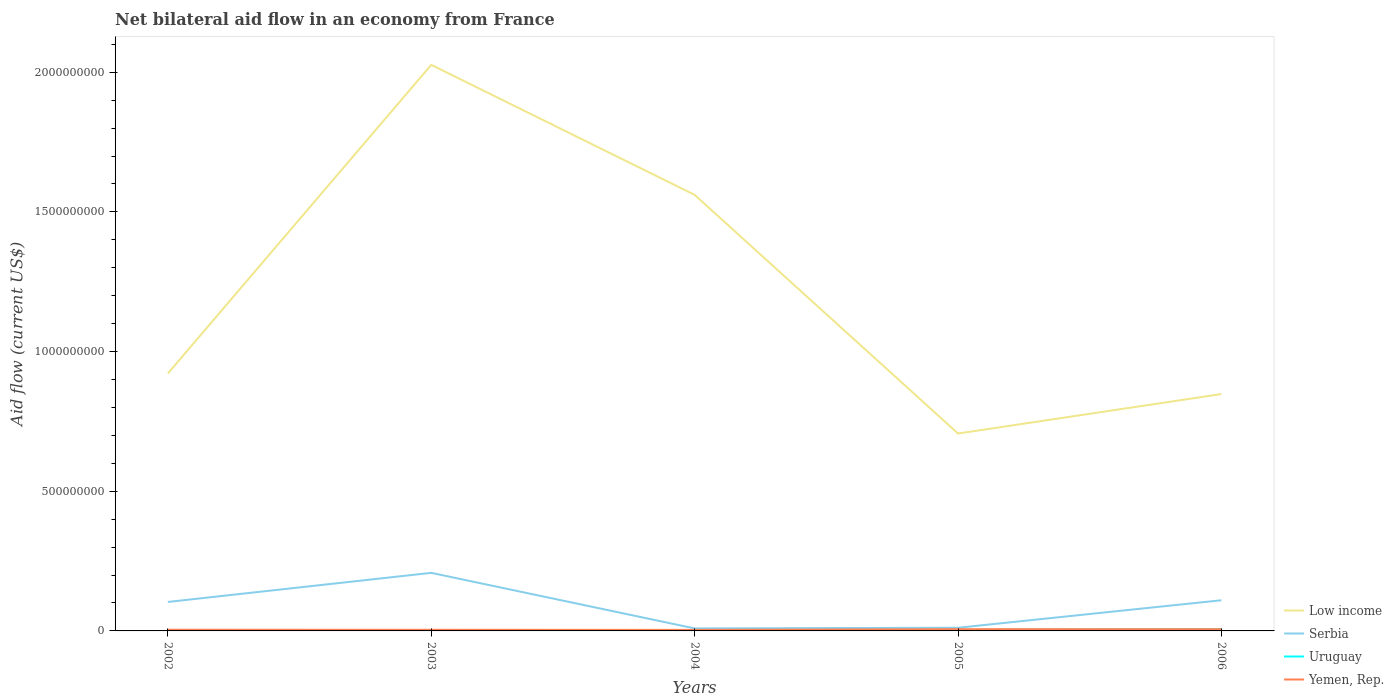Does the line corresponding to Low income intersect with the line corresponding to Uruguay?
Offer a terse response. No. Across all years, what is the maximum net bilateral aid flow in Low income?
Provide a short and direct response. 7.07e+08. What is the total net bilateral aid flow in Uruguay in the graph?
Keep it short and to the point. -3.06e+06. What is the difference between the highest and the second highest net bilateral aid flow in Serbia?
Provide a short and direct response. 1.99e+08. What is the difference between the highest and the lowest net bilateral aid flow in Yemen, Rep.?
Give a very brief answer. 2. Are the values on the major ticks of Y-axis written in scientific E-notation?
Your answer should be compact. No. How many legend labels are there?
Your response must be concise. 4. What is the title of the graph?
Offer a very short reply. Net bilateral aid flow in an economy from France. Does "Equatorial Guinea" appear as one of the legend labels in the graph?
Ensure brevity in your answer.  No. What is the label or title of the X-axis?
Ensure brevity in your answer.  Years. What is the label or title of the Y-axis?
Provide a short and direct response. Aid flow (current US$). What is the Aid flow (current US$) in Low income in 2002?
Your response must be concise. 9.22e+08. What is the Aid flow (current US$) in Serbia in 2002?
Provide a succinct answer. 1.04e+08. What is the Aid flow (current US$) in Uruguay in 2002?
Give a very brief answer. 2.39e+06. What is the Aid flow (current US$) of Yemen, Rep. in 2002?
Keep it short and to the point. 4.20e+06. What is the Aid flow (current US$) of Low income in 2003?
Ensure brevity in your answer.  2.03e+09. What is the Aid flow (current US$) of Serbia in 2003?
Offer a very short reply. 2.08e+08. What is the Aid flow (current US$) in Uruguay in 2003?
Make the answer very short. 1.96e+06. What is the Aid flow (current US$) in Yemen, Rep. in 2003?
Make the answer very short. 4.08e+06. What is the Aid flow (current US$) in Low income in 2004?
Provide a short and direct response. 1.56e+09. What is the Aid flow (current US$) in Serbia in 2004?
Your answer should be very brief. 8.95e+06. What is the Aid flow (current US$) of Uruguay in 2004?
Provide a short and direct response. 3.28e+06. What is the Aid flow (current US$) in Yemen, Rep. in 2004?
Offer a very short reply. 3.67e+06. What is the Aid flow (current US$) of Low income in 2005?
Offer a very short reply. 7.07e+08. What is the Aid flow (current US$) in Serbia in 2005?
Your response must be concise. 1.13e+07. What is the Aid flow (current US$) of Uruguay in 2005?
Offer a very short reply. 3.69e+06. What is the Aid flow (current US$) in Yemen, Rep. in 2005?
Ensure brevity in your answer.  6.19e+06. What is the Aid flow (current US$) of Low income in 2006?
Keep it short and to the point. 8.48e+08. What is the Aid flow (current US$) in Serbia in 2006?
Provide a short and direct response. 1.10e+08. What is the Aid flow (current US$) in Uruguay in 2006?
Your response must be concise. 6.34e+06. What is the Aid flow (current US$) in Yemen, Rep. in 2006?
Make the answer very short. 6.10e+06. Across all years, what is the maximum Aid flow (current US$) of Low income?
Your answer should be compact. 2.03e+09. Across all years, what is the maximum Aid flow (current US$) in Serbia?
Provide a short and direct response. 2.08e+08. Across all years, what is the maximum Aid flow (current US$) of Uruguay?
Your response must be concise. 6.34e+06. Across all years, what is the maximum Aid flow (current US$) of Yemen, Rep.?
Make the answer very short. 6.19e+06. Across all years, what is the minimum Aid flow (current US$) in Low income?
Offer a very short reply. 7.07e+08. Across all years, what is the minimum Aid flow (current US$) in Serbia?
Provide a short and direct response. 8.95e+06. Across all years, what is the minimum Aid flow (current US$) in Uruguay?
Provide a succinct answer. 1.96e+06. Across all years, what is the minimum Aid flow (current US$) of Yemen, Rep.?
Your answer should be compact. 3.67e+06. What is the total Aid flow (current US$) in Low income in the graph?
Provide a succinct answer. 6.06e+09. What is the total Aid flow (current US$) of Serbia in the graph?
Offer a very short reply. 4.42e+08. What is the total Aid flow (current US$) of Uruguay in the graph?
Offer a terse response. 1.77e+07. What is the total Aid flow (current US$) in Yemen, Rep. in the graph?
Offer a very short reply. 2.42e+07. What is the difference between the Aid flow (current US$) of Low income in 2002 and that in 2003?
Your response must be concise. -1.10e+09. What is the difference between the Aid flow (current US$) of Serbia in 2002 and that in 2003?
Offer a very short reply. -1.04e+08. What is the difference between the Aid flow (current US$) in Uruguay in 2002 and that in 2003?
Provide a short and direct response. 4.30e+05. What is the difference between the Aid flow (current US$) of Yemen, Rep. in 2002 and that in 2003?
Give a very brief answer. 1.20e+05. What is the difference between the Aid flow (current US$) in Low income in 2002 and that in 2004?
Provide a succinct answer. -6.40e+08. What is the difference between the Aid flow (current US$) of Serbia in 2002 and that in 2004?
Your answer should be very brief. 9.48e+07. What is the difference between the Aid flow (current US$) in Uruguay in 2002 and that in 2004?
Give a very brief answer. -8.90e+05. What is the difference between the Aid flow (current US$) of Yemen, Rep. in 2002 and that in 2004?
Provide a succinct answer. 5.30e+05. What is the difference between the Aid flow (current US$) of Low income in 2002 and that in 2005?
Your answer should be very brief. 2.15e+08. What is the difference between the Aid flow (current US$) of Serbia in 2002 and that in 2005?
Your response must be concise. 9.24e+07. What is the difference between the Aid flow (current US$) in Uruguay in 2002 and that in 2005?
Your answer should be very brief. -1.30e+06. What is the difference between the Aid flow (current US$) of Yemen, Rep. in 2002 and that in 2005?
Give a very brief answer. -1.99e+06. What is the difference between the Aid flow (current US$) of Low income in 2002 and that in 2006?
Your response must be concise. 7.36e+07. What is the difference between the Aid flow (current US$) of Serbia in 2002 and that in 2006?
Keep it short and to the point. -6.02e+06. What is the difference between the Aid flow (current US$) of Uruguay in 2002 and that in 2006?
Give a very brief answer. -3.95e+06. What is the difference between the Aid flow (current US$) of Yemen, Rep. in 2002 and that in 2006?
Provide a short and direct response. -1.90e+06. What is the difference between the Aid flow (current US$) of Low income in 2003 and that in 2004?
Provide a succinct answer. 4.65e+08. What is the difference between the Aid flow (current US$) in Serbia in 2003 and that in 2004?
Offer a terse response. 1.99e+08. What is the difference between the Aid flow (current US$) in Uruguay in 2003 and that in 2004?
Offer a terse response. -1.32e+06. What is the difference between the Aid flow (current US$) of Yemen, Rep. in 2003 and that in 2004?
Keep it short and to the point. 4.10e+05. What is the difference between the Aid flow (current US$) of Low income in 2003 and that in 2005?
Provide a short and direct response. 1.32e+09. What is the difference between the Aid flow (current US$) of Serbia in 2003 and that in 2005?
Your answer should be compact. 1.97e+08. What is the difference between the Aid flow (current US$) in Uruguay in 2003 and that in 2005?
Your answer should be very brief. -1.73e+06. What is the difference between the Aid flow (current US$) of Yemen, Rep. in 2003 and that in 2005?
Your answer should be compact. -2.11e+06. What is the difference between the Aid flow (current US$) in Low income in 2003 and that in 2006?
Your answer should be compact. 1.18e+09. What is the difference between the Aid flow (current US$) of Serbia in 2003 and that in 2006?
Ensure brevity in your answer.  9.81e+07. What is the difference between the Aid flow (current US$) of Uruguay in 2003 and that in 2006?
Provide a short and direct response. -4.38e+06. What is the difference between the Aid flow (current US$) of Yemen, Rep. in 2003 and that in 2006?
Your response must be concise. -2.02e+06. What is the difference between the Aid flow (current US$) of Low income in 2004 and that in 2005?
Your response must be concise. 8.54e+08. What is the difference between the Aid flow (current US$) of Serbia in 2004 and that in 2005?
Offer a very short reply. -2.39e+06. What is the difference between the Aid flow (current US$) in Uruguay in 2004 and that in 2005?
Offer a terse response. -4.10e+05. What is the difference between the Aid flow (current US$) in Yemen, Rep. in 2004 and that in 2005?
Provide a succinct answer. -2.52e+06. What is the difference between the Aid flow (current US$) of Low income in 2004 and that in 2006?
Offer a very short reply. 7.13e+08. What is the difference between the Aid flow (current US$) of Serbia in 2004 and that in 2006?
Your answer should be compact. -1.01e+08. What is the difference between the Aid flow (current US$) in Uruguay in 2004 and that in 2006?
Ensure brevity in your answer.  -3.06e+06. What is the difference between the Aid flow (current US$) of Yemen, Rep. in 2004 and that in 2006?
Provide a succinct answer. -2.43e+06. What is the difference between the Aid flow (current US$) in Low income in 2005 and that in 2006?
Ensure brevity in your answer.  -1.41e+08. What is the difference between the Aid flow (current US$) in Serbia in 2005 and that in 2006?
Make the answer very short. -9.84e+07. What is the difference between the Aid flow (current US$) in Uruguay in 2005 and that in 2006?
Offer a very short reply. -2.65e+06. What is the difference between the Aid flow (current US$) of Low income in 2002 and the Aid flow (current US$) of Serbia in 2003?
Ensure brevity in your answer.  7.14e+08. What is the difference between the Aid flow (current US$) of Low income in 2002 and the Aid flow (current US$) of Uruguay in 2003?
Provide a succinct answer. 9.20e+08. What is the difference between the Aid flow (current US$) of Low income in 2002 and the Aid flow (current US$) of Yemen, Rep. in 2003?
Provide a short and direct response. 9.17e+08. What is the difference between the Aid flow (current US$) of Serbia in 2002 and the Aid flow (current US$) of Uruguay in 2003?
Keep it short and to the point. 1.02e+08. What is the difference between the Aid flow (current US$) in Serbia in 2002 and the Aid flow (current US$) in Yemen, Rep. in 2003?
Your answer should be compact. 9.97e+07. What is the difference between the Aid flow (current US$) of Uruguay in 2002 and the Aid flow (current US$) of Yemen, Rep. in 2003?
Your response must be concise. -1.69e+06. What is the difference between the Aid flow (current US$) in Low income in 2002 and the Aid flow (current US$) in Serbia in 2004?
Your response must be concise. 9.13e+08. What is the difference between the Aid flow (current US$) of Low income in 2002 and the Aid flow (current US$) of Uruguay in 2004?
Offer a very short reply. 9.18e+08. What is the difference between the Aid flow (current US$) of Low income in 2002 and the Aid flow (current US$) of Yemen, Rep. in 2004?
Offer a very short reply. 9.18e+08. What is the difference between the Aid flow (current US$) in Serbia in 2002 and the Aid flow (current US$) in Uruguay in 2004?
Provide a short and direct response. 1.00e+08. What is the difference between the Aid flow (current US$) in Serbia in 2002 and the Aid flow (current US$) in Yemen, Rep. in 2004?
Make the answer very short. 1.00e+08. What is the difference between the Aid flow (current US$) of Uruguay in 2002 and the Aid flow (current US$) of Yemen, Rep. in 2004?
Ensure brevity in your answer.  -1.28e+06. What is the difference between the Aid flow (current US$) in Low income in 2002 and the Aid flow (current US$) in Serbia in 2005?
Provide a succinct answer. 9.10e+08. What is the difference between the Aid flow (current US$) of Low income in 2002 and the Aid flow (current US$) of Uruguay in 2005?
Provide a short and direct response. 9.18e+08. What is the difference between the Aid flow (current US$) of Low income in 2002 and the Aid flow (current US$) of Yemen, Rep. in 2005?
Ensure brevity in your answer.  9.15e+08. What is the difference between the Aid flow (current US$) of Serbia in 2002 and the Aid flow (current US$) of Uruguay in 2005?
Give a very brief answer. 1.00e+08. What is the difference between the Aid flow (current US$) in Serbia in 2002 and the Aid flow (current US$) in Yemen, Rep. in 2005?
Provide a short and direct response. 9.76e+07. What is the difference between the Aid flow (current US$) of Uruguay in 2002 and the Aid flow (current US$) of Yemen, Rep. in 2005?
Provide a short and direct response. -3.80e+06. What is the difference between the Aid flow (current US$) in Low income in 2002 and the Aid flow (current US$) in Serbia in 2006?
Ensure brevity in your answer.  8.12e+08. What is the difference between the Aid flow (current US$) of Low income in 2002 and the Aid flow (current US$) of Uruguay in 2006?
Offer a very short reply. 9.15e+08. What is the difference between the Aid flow (current US$) of Low income in 2002 and the Aid flow (current US$) of Yemen, Rep. in 2006?
Your answer should be compact. 9.15e+08. What is the difference between the Aid flow (current US$) of Serbia in 2002 and the Aid flow (current US$) of Uruguay in 2006?
Your answer should be compact. 9.74e+07. What is the difference between the Aid flow (current US$) of Serbia in 2002 and the Aid flow (current US$) of Yemen, Rep. in 2006?
Provide a short and direct response. 9.76e+07. What is the difference between the Aid flow (current US$) of Uruguay in 2002 and the Aid flow (current US$) of Yemen, Rep. in 2006?
Make the answer very short. -3.71e+06. What is the difference between the Aid flow (current US$) of Low income in 2003 and the Aid flow (current US$) of Serbia in 2004?
Provide a succinct answer. 2.02e+09. What is the difference between the Aid flow (current US$) of Low income in 2003 and the Aid flow (current US$) of Uruguay in 2004?
Make the answer very short. 2.02e+09. What is the difference between the Aid flow (current US$) of Low income in 2003 and the Aid flow (current US$) of Yemen, Rep. in 2004?
Your answer should be very brief. 2.02e+09. What is the difference between the Aid flow (current US$) in Serbia in 2003 and the Aid flow (current US$) in Uruguay in 2004?
Make the answer very short. 2.05e+08. What is the difference between the Aid flow (current US$) of Serbia in 2003 and the Aid flow (current US$) of Yemen, Rep. in 2004?
Provide a succinct answer. 2.04e+08. What is the difference between the Aid flow (current US$) of Uruguay in 2003 and the Aid flow (current US$) of Yemen, Rep. in 2004?
Provide a succinct answer. -1.71e+06. What is the difference between the Aid flow (current US$) in Low income in 2003 and the Aid flow (current US$) in Serbia in 2005?
Provide a succinct answer. 2.02e+09. What is the difference between the Aid flow (current US$) in Low income in 2003 and the Aid flow (current US$) in Uruguay in 2005?
Your answer should be very brief. 2.02e+09. What is the difference between the Aid flow (current US$) of Low income in 2003 and the Aid flow (current US$) of Yemen, Rep. in 2005?
Give a very brief answer. 2.02e+09. What is the difference between the Aid flow (current US$) of Serbia in 2003 and the Aid flow (current US$) of Uruguay in 2005?
Make the answer very short. 2.04e+08. What is the difference between the Aid flow (current US$) of Serbia in 2003 and the Aid flow (current US$) of Yemen, Rep. in 2005?
Your response must be concise. 2.02e+08. What is the difference between the Aid flow (current US$) in Uruguay in 2003 and the Aid flow (current US$) in Yemen, Rep. in 2005?
Offer a very short reply. -4.23e+06. What is the difference between the Aid flow (current US$) in Low income in 2003 and the Aid flow (current US$) in Serbia in 2006?
Your response must be concise. 1.92e+09. What is the difference between the Aid flow (current US$) in Low income in 2003 and the Aid flow (current US$) in Uruguay in 2006?
Keep it short and to the point. 2.02e+09. What is the difference between the Aid flow (current US$) of Low income in 2003 and the Aid flow (current US$) of Yemen, Rep. in 2006?
Your answer should be compact. 2.02e+09. What is the difference between the Aid flow (current US$) of Serbia in 2003 and the Aid flow (current US$) of Uruguay in 2006?
Give a very brief answer. 2.02e+08. What is the difference between the Aid flow (current US$) in Serbia in 2003 and the Aid flow (current US$) in Yemen, Rep. in 2006?
Provide a succinct answer. 2.02e+08. What is the difference between the Aid flow (current US$) of Uruguay in 2003 and the Aid flow (current US$) of Yemen, Rep. in 2006?
Ensure brevity in your answer.  -4.14e+06. What is the difference between the Aid flow (current US$) of Low income in 2004 and the Aid flow (current US$) of Serbia in 2005?
Your answer should be compact. 1.55e+09. What is the difference between the Aid flow (current US$) in Low income in 2004 and the Aid flow (current US$) in Uruguay in 2005?
Your answer should be compact. 1.56e+09. What is the difference between the Aid flow (current US$) of Low income in 2004 and the Aid flow (current US$) of Yemen, Rep. in 2005?
Offer a very short reply. 1.55e+09. What is the difference between the Aid flow (current US$) in Serbia in 2004 and the Aid flow (current US$) in Uruguay in 2005?
Give a very brief answer. 5.26e+06. What is the difference between the Aid flow (current US$) in Serbia in 2004 and the Aid flow (current US$) in Yemen, Rep. in 2005?
Give a very brief answer. 2.76e+06. What is the difference between the Aid flow (current US$) in Uruguay in 2004 and the Aid flow (current US$) in Yemen, Rep. in 2005?
Provide a succinct answer. -2.91e+06. What is the difference between the Aid flow (current US$) of Low income in 2004 and the Aid flow (current US$) of Serbia in 2006?
Give a very brief answer. 1.45e+09. What is the difference between the Aid flow (current US$) in Low income in 2004 and the Aid flow (current US$) in Uruguay in 2006?
Make the answer very short. 1.55e+09. What is the difference between the Aid flow (current US$) of Low income in 2004 and the Aid flow (current US$) of Yemen, Rep. in 2006?
Your answer should be very brief. 1.55e+09. What is the difference between the Aid flow (current US$) in Serbia in 2004 and the Aid flow (current US$) in Uruguay in 2006?
Your answer should be compact. 2.61e+06. What is the difference between the Aid flow (current US$) of Serbia in 2004 and the Aid flow (current US$) of Yemen, Rep. in 2006?
Offer a very short reply. 2.85e+06. What is the difference between the Aid flow (current US$) in Uruguay in 2004 and the Aid flow (current US$) in Yemen, Rep. in 2006?
Keep it short and to the point. -2.82e+06. What is the difference between the Aid flow (current US$) in Low income in 2005 and the Aid flow (current US$) in Serbia in 2006?
Make the answer very short. 5.97e+08. What is the difference between the Aid flow (current US$) of Low income in 2005 and the Aid flow (current US$) of Uruguay in 2006?
Provide a short and direct response. 7.00e+08. What is the difference between the Aid flow (current US$) of Low income in 2005 and the Aid flow (current US$) of Yemen, Rep. in 2006?
Offer a terse response. 7.01e+08. What is the difference between the Aid flow (current US$) in Serbia in 2005 and the Aid flow (current US$) in Yemen, Rep. in 2006?
Your answer should be very brief. 5.24e+06. What is the difference between the Aid flow (current US$) of Uruguay in 2005 and the Aid flow (current US$) of Yemen, Rep. in 2006?
Offer a very short reply. -2.41e+06. What is the average Aid flow (current US$) in Low income per year?
Offer a terse response. 1.21e+09. What is the average Aid flow (current US$) in Serbia per year?
Keep it short and to the point. 8.83e+07. What is the average Aid flow (current US$) in Uruguay per year?
Provide a succinct answer. 3.53e+06. What is the average Aid flow (current US$) of Yemen, Rep. per year?
Keep it short and to the point. 4.85e+06. In the year 2002, what is the difference between the Aid flow (current US$) of Low income and Aid flow (current US$) of Serbia?
Make the answer very short. 8.18e+08. In the year 2002, what is the difference between the Aid flow (current US$) of Low income and Aid flow (current US$) of Uruguay?
Your answer should be very brief. 9.19e+08. In the year 2002, what is the difference between the Aid flow (current US$) in Low income and Aid flow (current US$) in Yemen, Rep.?
Your answer should be compact. 9.17e+08. In the year 2002, what is the difference between the Aid flow (current US$) of Serbia and Aid flow (current US$) of Uruguay?
Your response must be concise. 1.01e+08. In the year 2002, what is the difference between the Aid flow (current US$) in Serbia and Aid flow (current US$) in Yemen, Rep.?
Ensure brevity in your answer.  9.95e+07. In the year 2002, what is the difference between the Aid flow (current US$) in Uruguay and Aid flow (current US$) in Yemen, Rep.?
Your answer should be compact. -1.81e+06. In the year 2003, what is the difference between the Aid flow (current US$) in Low income and Aid flow (current US$) in Serbia?
Your response must be concise. 1.82e+09. In the year 2003, what is the difference between the Aid flow (current US$) of Low income and Aid flow (current US$) of Uruguay?
Offer a terse response. 2.02e+09. In the year 2003, what is the difference between the Aid flow (current US$) in Low income and Aid flow (current US$) in Yemen, Rep.?
Ensure brevity in your answer.  2.02e+09. In the year 2003, what is the difference between the Aid flow (current US$) of Serbia and Aid flow (current US$) of Uruguay?
Make the answer very short. 2.06e+08. In the year 2003, what is the difference between the Aid flow (current US$) of Serbia and Aid flow (current US$) of Yemen, Rep.?
Offer a terse response. 2.04e+08. In the year 2003, what is the difference between the Aid flow (current US$) in Uruguay and Aid flow (current US$) in Yemen, Rep.?
Keep it short and to the point. -2.12e+06. In the year 2004, what is the difference between the Aid flow (current US$) in Low income and Aid flow (current US$) in Serbia?
Ensure brevity in your answer.  1.55e+09. In the year 2004, what is the difference between the Aid flow (current US$) of Low income and Aid flow (current US$) of Uruguay?
Give a very brief answer. 1.56e+09. In the year 2004, what is the difference between the Aid flow (current US$) of Low income and Aid flow (current US$) of Yemen, Rep.?
Your answer should be very brief. 1.56e+09. In the year 2004, what is the difference between the Aid flow (current US$) in Serbia and Aid flow (current US$) in Uruguay?
Give a very brief answer. 5.67e+06. In the year 2004, what is the difference between the Aid flow (current US$) in Serbia and Aid flow (current US$) in Yemen, Rep.?
Make the answer very short. 5.28e+06. In the year 2004, what is the difference between the Aid flow (current US$) of Uruguay and Aid flow (current US$) of Yemen, Rep.?
Provide a short and direct response. -3.90e+05. In the year 2005, what is the difference between the Aid flow (current US$) of Low income and Aid flow (current US$) of Serbia?
Your response must be concise. 6.95e+08. In the year 2005, what is the difference between the Aid flow (current US$) of Low income and Aid flow (current US$) of Uruguay?
Your answer should be very brief. 7.03e+08. In the year 2005, what is the difference between the Aid flow (current US$) of Low income and Aid flow (current US$) of Yemen, Rep.?
Provide a succinct answer. 7.00e+08. In the year 2005, what is the difference between the Aid flow (current US$) of Serbia and Aid flow (current US$) of Uruguay?
Your answer should be very brief. 7.65e+06. In the year 2005, what is the difference between the Aid flow (current US$) of Serbia and Aid flow (current US$) of Yemen, Rep.?
Your response must be concise. 5.15e+06. In the year 2005, what is the difference between the Aid flow (current US$) of Uruguay and Aid flow (current US$) of Yemen, Rep.?
Give a very brief answer. -2.50e+06. In the year 2006, what is the difference between the Aid flow (current US$) in Low income and Aid flow (current US$) in Serbia?
Provide a short and direct response. 7.38e+08. In the year 2006, what is the difference between the Aid flow (current US$) in Low income and Aid flow (current US$) in Uruguay?
Your answer should be very brief. 8.42e+08. In the year 2006, what is the difference between the Aid flow (current US$) of Low income and Aid flow (current US$) of Yemen, Rep.?
Keep it short and to the point. 8.42e+08. In the year 2006, what is the difference between the Aid flow (current US$) of Serbia and Aid flow (current US$) of Uruguay?
Your answer should be very brief. 1.03e+08. In the year 2006, what is the difference between the Aid flow (current US$) in Serbia and Aid flow (current US$) in Yemen, Rep.?
Your answer should be very brief. 1.04e+08. What is the ratio of the Aid flow (current US$) of Low income in 2002 to that in 2003?
Your answer should be compact. 0.45. What is the ratio of the Aid flow (current US$) of Serbia in 2002 to that in 2003?
Offer a very short reply. 0.5. What is the ratio of the Aid flow (current US$) of Uruguay in 2002 to that in 2003?
Your answer should be compact. 1.22. What is the ratio of the Aid flow (current US$) of Yemen, Rep. in 2002 to that in 2003?
Keep it short and to the point. 1.03. What is the ratio of the Aid flow (current US$) in Low income in 2002 to that in 2004?
Your answer should be very brief. 0.59. What is the ratio of the Aid flow (current US$) of Serbia in 2002 to that in 2004?
Keep it short and to the point. 11.59. What is the ratio of the Aid flow (current US$) of Uruguay in 2002 to that in 2004?
Provide a succinct answer. 0.73. What is the ratio of the Aid flow (current US$) of Yemen, Rep. in 2002 to that in 2004?
Your answer should be compact. 1.14. What is the ratio of the Aid flow (current US$) of Low income in 2002 to that in 2005?
Offer a very short reply. 1.3. What is the ratio of the Aid flow (current US$) in Serbia in 2002 to that in 2005?
Provide a succinct answer. 9.15. What is the ratio of the Aid flow (current US$) in Uruguay in 2002 to that in 2005?
Your answer should be compact. 0.65. What is the ratio of the Aid flow (current US$) in Yemen, Rep. in 2002 to that in 2005?
Your answer should be compact. 0.68. What is the ratio of the Aid flow (current US$) of Low income in 2002 to that in 2006?
Provide a short and direct response. 1.09. What is the ratio of the Aid flow (current US$) of Serbia in 2002 to that in 2006?
Provide a succinct answer. 0.95. What is the ratio of the Aid flow (current US$) in Uruguay in 2002 to that in 2006?
Provide a short and direct response. 0.38. What is the ratio of the Aid flow (current US$) of Yemen, Rep. in 2002 to that in 2006?
Offer a terse response. 0.69. What is the ratio of the Aid flow (current US$) in Low income in 2003 to that in 2004?
Provide a succinct answer. 1.3. What is the ratio of the Aid flow (current US$) of Serbia in 2003 to that in 2004?
Provide a succinct answer. 23.23. What is the ratio of the Aid flow (current US$) in Uruguay in 2003 to that in 2004?
Provide a short and direct response. 0.6. What is the ratio of the Aid flow (current US$) of Yemen, Rep. in 2003 to that in 2004?
Give a very brief answer. 1.11. What is the ratio of the Aid flow (current US$) in Low income in 2003 to that in 2005?
Give a very brief answer. 2.87. What is the ratio of the Aid flow (current US$) of Serbia in 2003 to that in 2005?
Offer a terse response. 18.33. What is the ratio of the Aid flow (current US$) of Uruguay in 2003 to that in 2005?
Offer a very short reply. 0.53. What is the ratio of the Aid flow (current US$) in Yemen, Rep. in 2003 to that in 2005?
Your response must be concise. 0.66. What is the ratio of the Aid flow (current US$) in Low income in 2003 to that in 2006?
Keep it short and to the point. 2.39. What is the ratio of the Aid flow (current US$) in Serbia in 2003 to that in 2006?
Provide a succinct answer. 1.89. What is the ratio of the Aid flow (current US$) of Uruguay in 2003 to that in 2006?
Keep it short and to the point. 0.31. What is the ratio of the Aid flow (current US$) in Yemen, Rep. in 2003 to that in 2006?
Your answer should be compact. 0.67. What is the ratio of the Aid flow (current US$) of Low income in 2004 to that in 2005?
Offer a very short reply. 2.21. What is the ratio of the Aid flow (current US$) in Serbia in 2004 to that in 2005?
Provide a succinct answer. 0.79. What is the ratio of the Aid flow (current US$) of Yemen, Rep. in 2004 to that in 2005?
Your response must be concise. 0.59. What is the ratio of the Aid flow (current US$) of Low income in 2004 to that in 2006?
Ensure brevity in your answer.  1.84. What is the ratio of the Aid flow (current US$) in Serbia in 2004 to that in 2006?
Offer a terse response. 0.08. What is the ratio of the Aid flow (current US$) in Uruguay in 2004 to that in 2006?
Offer a terse response. 0.52. What is the ratio of the Aid flow (current US$) in Yemen, Rep. in 2004 to that in 2006?
Your answer should be compact. 0.6. What is the ratio of the Aid flow (current US$) in Low income in 2005 to that in 2006?
Offer a very short reply. 0.83. What is the ratio of the Aid flow (current US$) of Serbia in 2005 to that in 2006?
Offer a very short reply. 0.1. What is the ratio of the Aid flow (current US$) in Uruguay in 2005 to that in 2006?
Keep it short and to the point. 0.58. What is the ratio of the Aid flow (current US$) of Yemen, Rep. in 2005 to that in 2006?
Your answer should be compact. 1.01. What is the difference between the highest and the second highest Aid flow (current US$) of Low income?
Keep it short and to the point. 4.65e+08. What is the difference between the highest and the second highest Aid flow (current US$) in Serbia?
Your answer should be compact. 9.81e+07. What is the difference between the highest and the second highest Aid flow (current US$) in Uruguay?
Provide a succinct answer. 2.65e+06. What is the difference between the highest and the second highest Aid flow (current US$) of Yemen, Rep.?
Offer a very short reply. 9.00e+04. What is the difference between the highest and the lowest Aid flow (current US$) in Low income?
Your response must be concise. 1.32e+09. What is the difference between the highest and the lowest Aid flow (current US$) in Serbia?
Ensure brevity in your answer.  1.99e+08. What is the difference between the highest and the lowest Aid flow (current US$) of Uruguay?
Your response must be concise. 4.38e+06. What is the difference between the highest and the lowest Aid flow (current US$) in Yemen, Rep.?
Your response must be concise. 2.52e+06. 